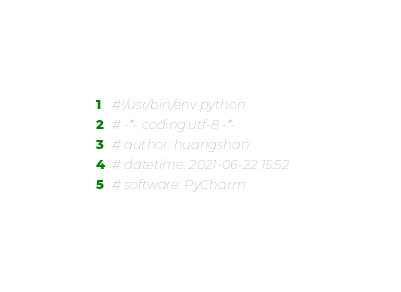Convert code to text. <code><loc_0><loc_0><loc_500><loc_500><_Python_>#!/usr/bin/env python
# -*- coding:utf-8 -*-
# author: huangshan
# datetime: 2021-06-22 15:52
# software: PyCharm</code> 